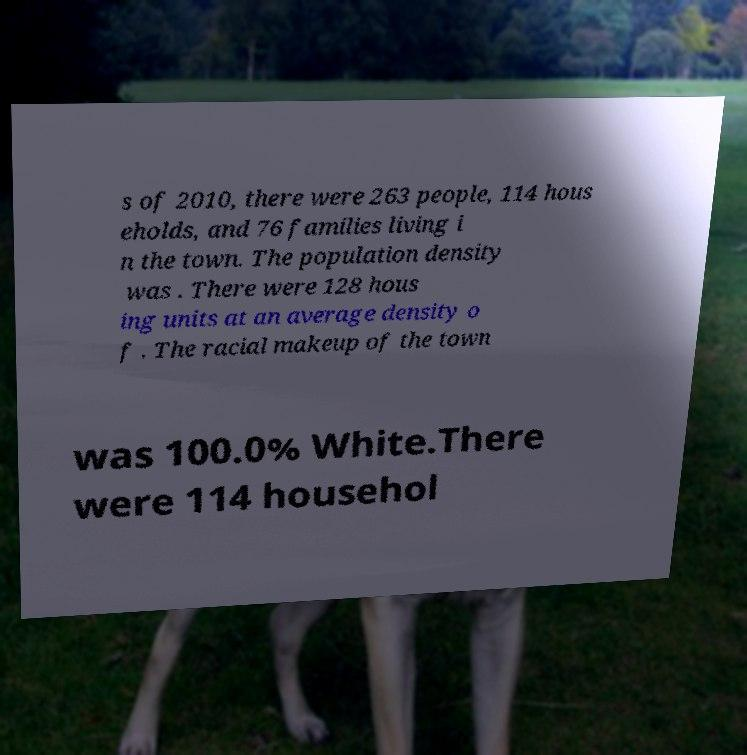For documentation purposes, I need the text within this image transcribed. Could you provide that? s of 2010, there were 263 people, 114 hous eholds, and 76 families living i n the town. The population density was . There were 128 hous ing units at an average density o f . The racial makeup of the town was 100.0% White.There were 114 househol 